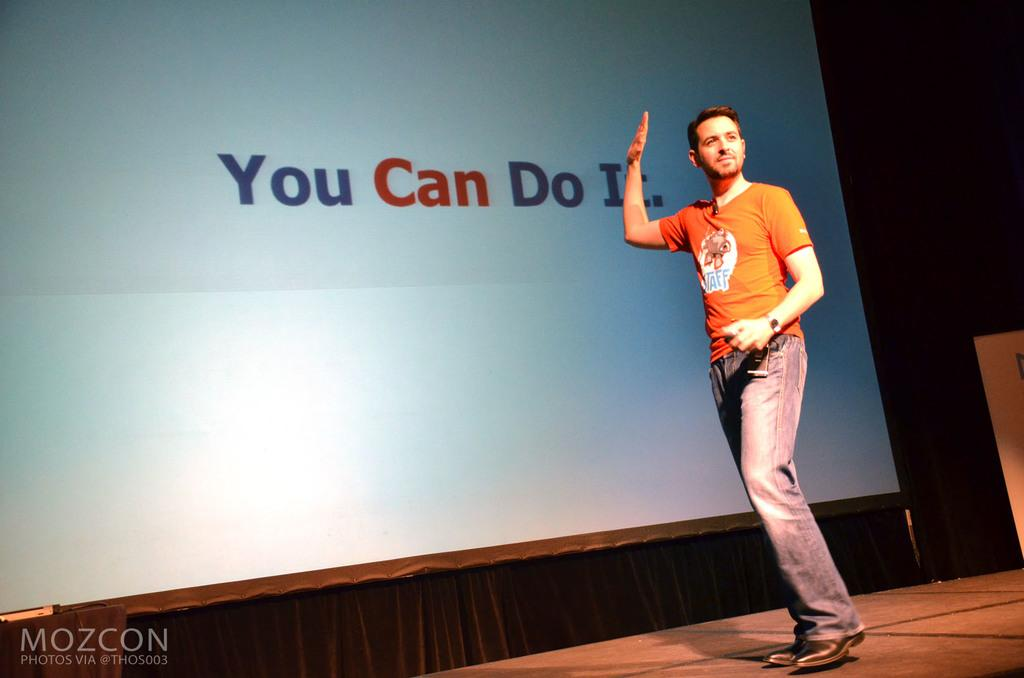Who or what is the main subject in the image? There is a person in the image. Can you describe the person's attire? The person is wearing clothes. What is the person standing in front of? The person is standing in front of a screen. Is there any text visible in the image? Yes, there is text in the bottom left of the image. What type of stone can be seen in the person's hand in the image? There is no stone present in the person's hand or in the image. How many clams are visible on the screen in the image? There are no clams visible on screen or in the image. 